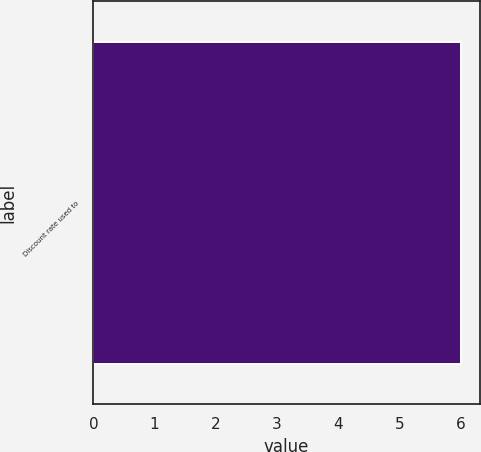Convert chart to OTSL. <chart><loc_0><loc_0><loc_500><loc_500><bar_chart><fcel>Discount rate used to<nl><fcel>6.01<nl></chart> 